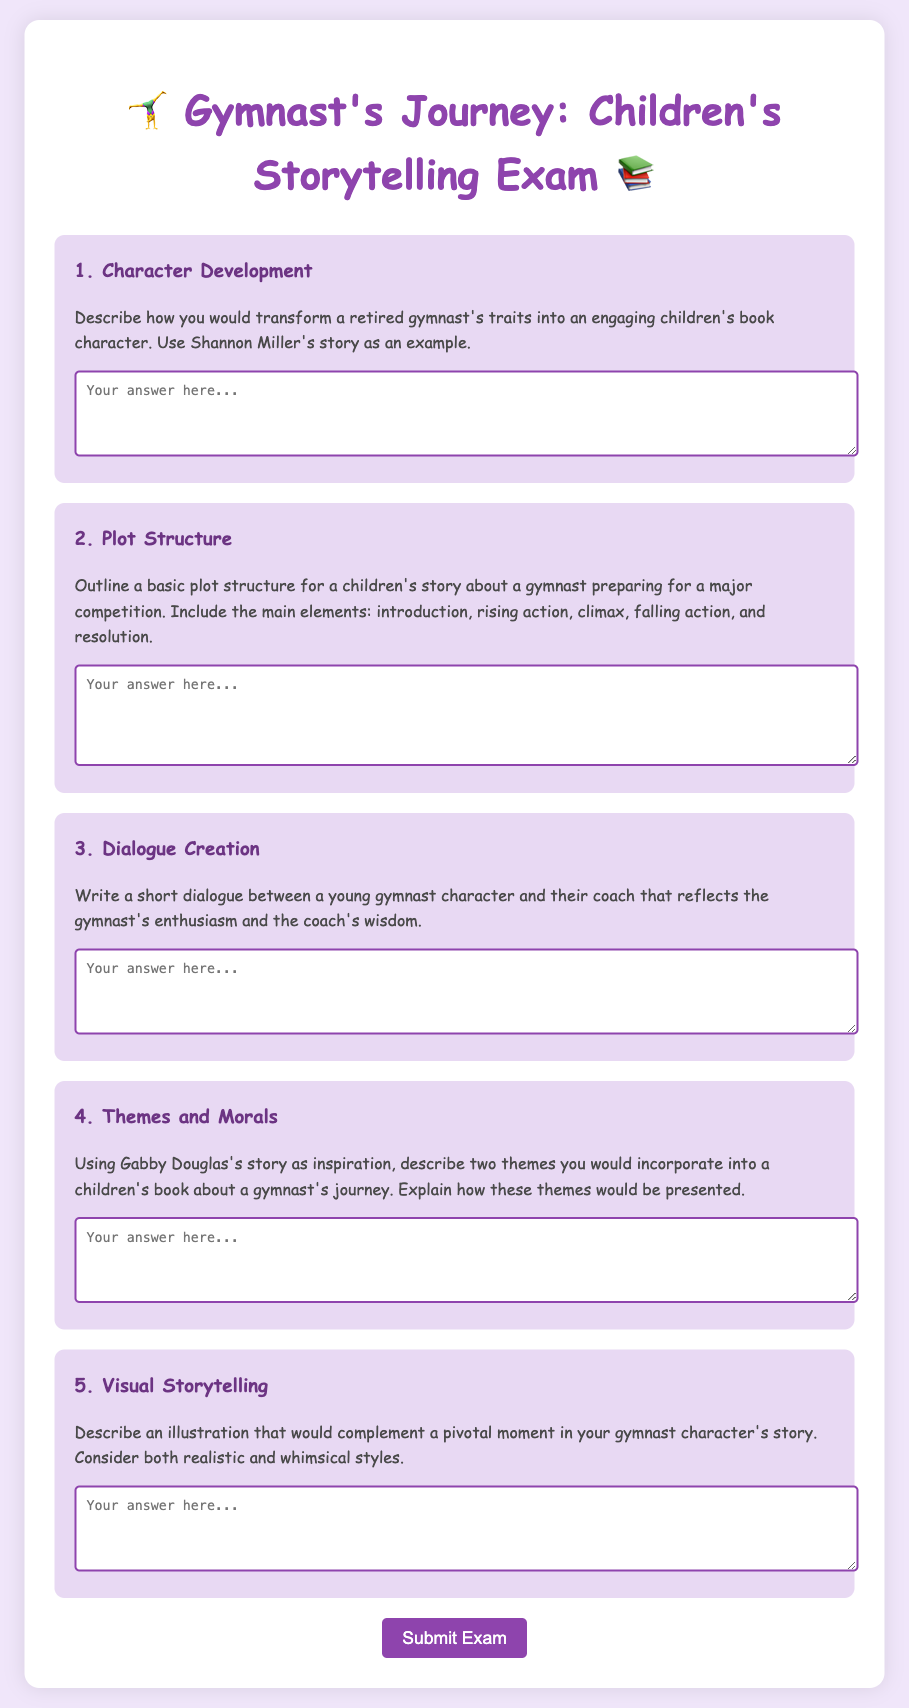What is the title of the exam? The title of the exam is displayed prominently at the top of the document.
Answer: Gymnast's Journey: Children's Storytelling Exam How many questions are included in the document? By counting the sections that contain questions, we find there are five distinct questions.
Answer: 5 What is the color of the submit button? The document specifies the background color of the button using a specific color code, which is visually represented.
Answer: #8e44ad Which character is mentioned as an example for character development? The document provides a specific retired gymnast's name as an example for transforming traits into a character.
Answer: Shannon Miller What is the main theme of the second question? The second question requires outlining a specific narrative structure relevant to a children's story.
Answer: Plot Structure What does the fourth question ask about? The fourth question prompts the respondent to discuss themes and how they relate to a specific story.
Answer: Themes and Morals In which section would you find dialogue creation? This particular section can be identified by its title, which directly indicates the skill being assessed.
Answer: Dialogue Creation What kind of style is mentioned for illustrations in the fifth question? The fifth question highlights different artistic approaches that could be used for visual storytelling.
Answer: Realistic and whimsical styles How is the text displayed in the document styled? The style of the text is set throughout the document with specific attributes like font and color for readability and appeal.
Answer: Comic Sans MS 